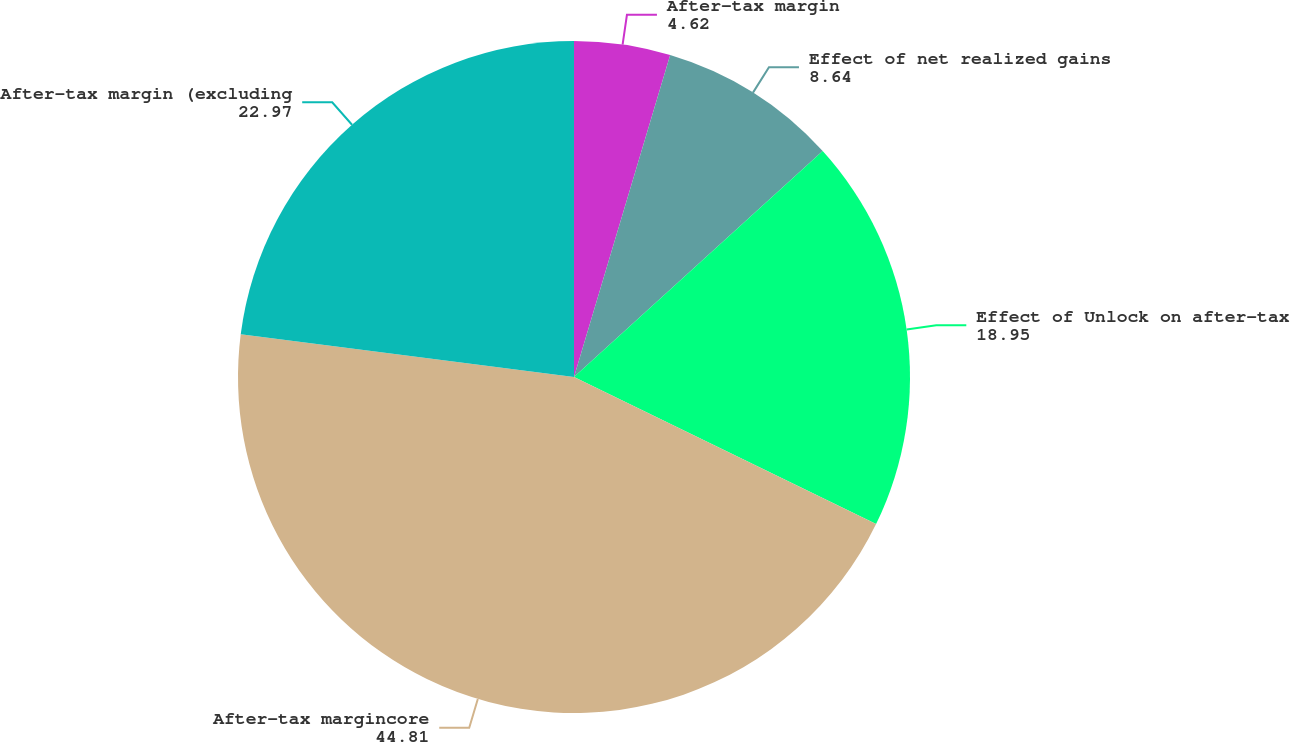Convert chart to OTSL. <chart><loc_0><loc_0><loc_500><loc_500><pie_chart><fcel>After-tax margin<fcel>Effect of net realized gains<fcel>Effect of Unlock on after-tax<fcel>After-tax margincore<fcel>After-tax margin (excluding<nl><fcel>4.62%<fcel>8.64%<fcel>18.95%<fcel>44.81%<fcel>22.97%<nl></chart> 